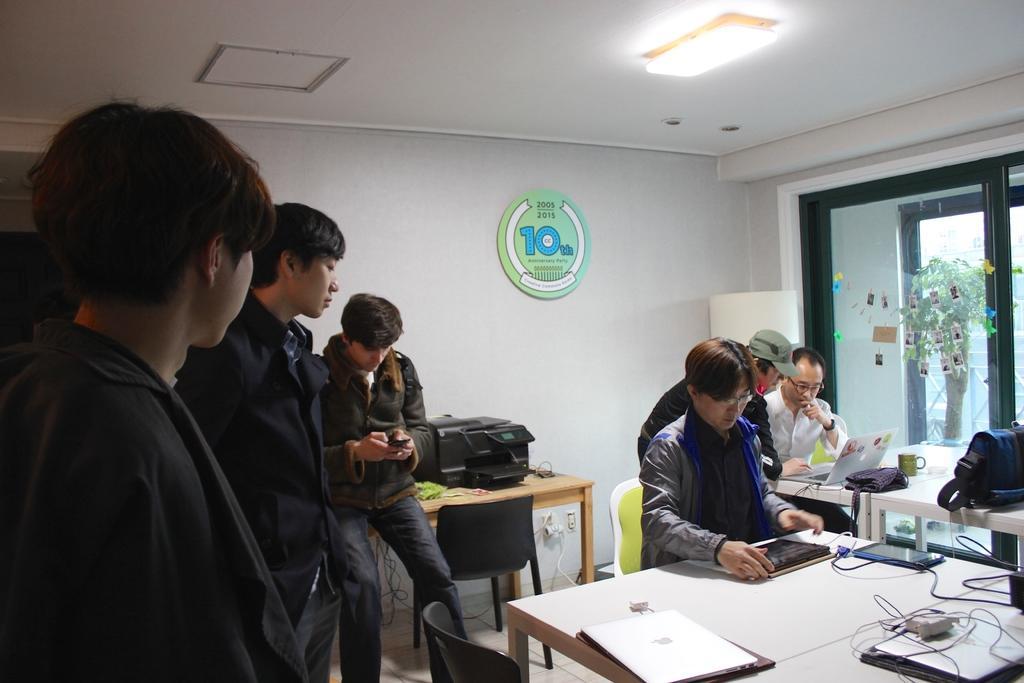Can you describe this image briefly? In this picture there are group of people those who are standing at the left side of the image and there are two people those who are sitting on the chairs with laptops, there is a table and a printer above the table, there is a window at the right side of the image, it seems to be a staff room. 